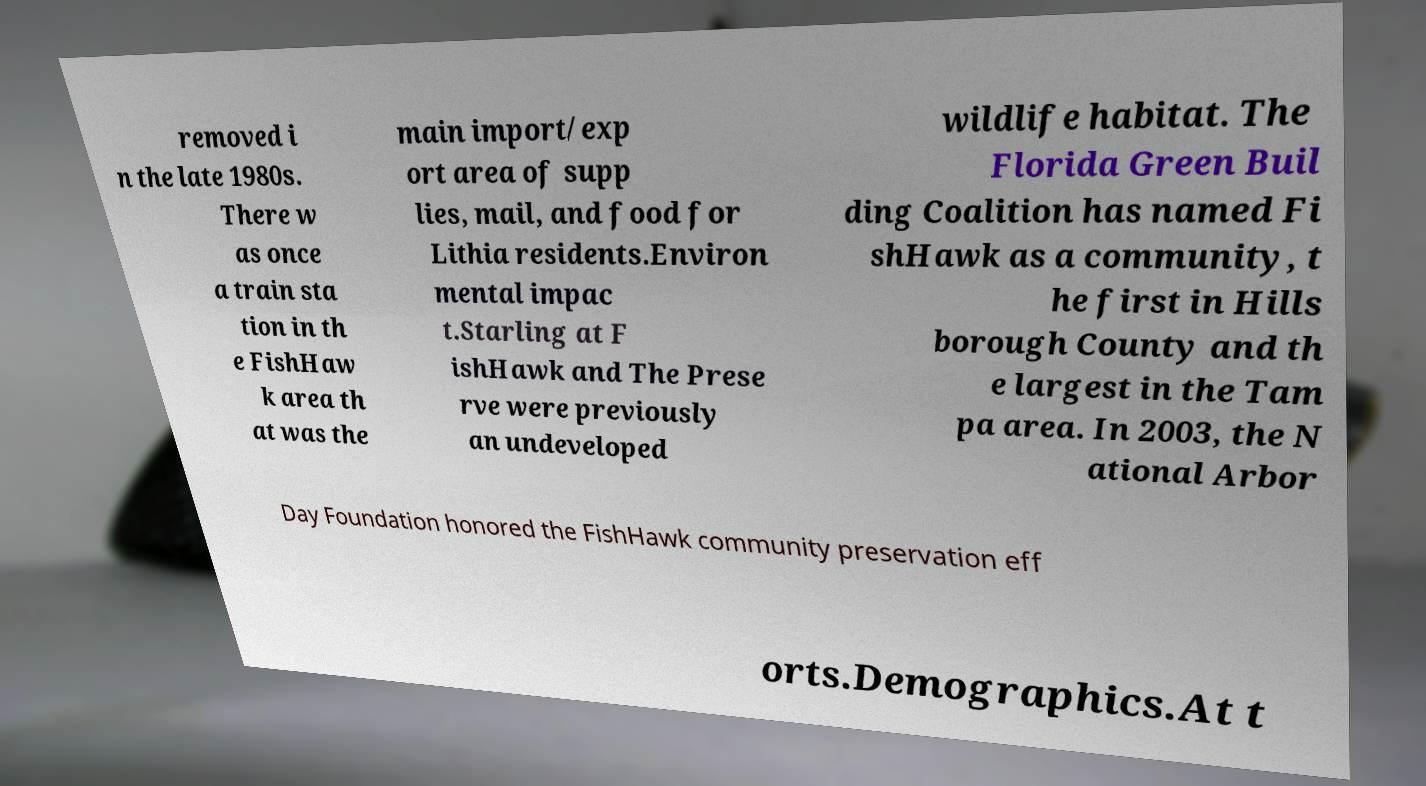Can you accurately transcribe the text from the provided image for me? removed i n the late 1980s. There w as once a train sta tion in th e FishHaw k area th at was the main import/exp ort area of supp lies, mail, and food for Lithia residents.Environ mental impac t.Starling at F ishHawk and The Prese rve were previously an undeveloped wildlife habitat. The Florida Green Buil ding Coalition has named Fi shHawk as a community, t he first in Hills borough County and th e largest in the Tam pa area. In 2003, the N ational Arbor Day Foundation honored the FishHawk community preservation eff orts.Demographics.At t 